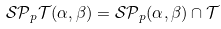Convert formula to latex. <formula><loc_0><loc_0><loc_500><loc_500>\mathcal { S P } _ { p } \mathcal { T } ( \alpha , \beta ) = \mathcal { S P } _ { p } ( \alpha , \beta ) \cap \mathcal { T }</formula> 